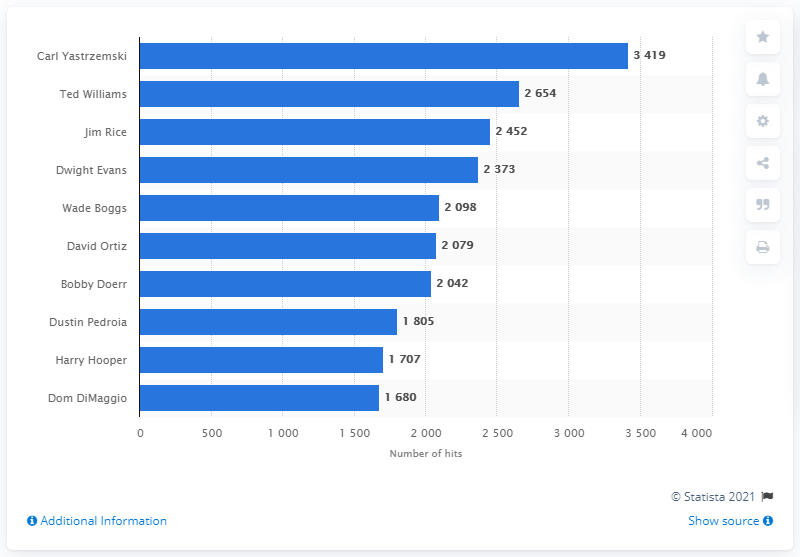Give some essential details in this illustration. Carl Yastrzemski is the Boston Red Sox franchise history holder with the most hits. 